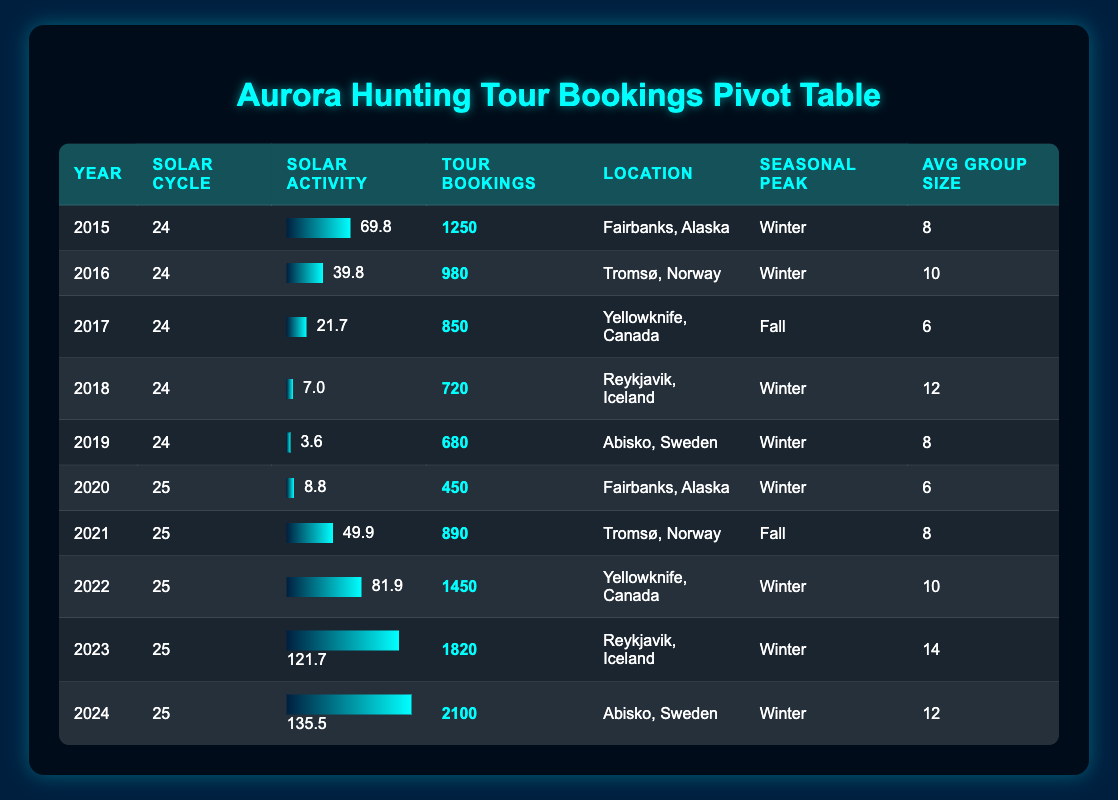What was the year with the highest solar activity index? Looking through the table, the highest solar activity index of 135.5 occurs in the year 2024.
Answer: 2024 Which location had the lowest number of tour bookings? The table shows that the lowest number of tour bookings is 450, which occurred in Fairbanks, Alaska in 2020.
Answer: Fairbanks, Alaska What is the average number of tour bookings for the years 2015 to 2023? Adding all tour bookings from 2015 to 2023 gives (1250 + 980 + 850 + 720 + 680 + 450 + 890 + 1450 + 1820) = 8150. There are 9 data points, so the average is 8150/9 = approximately 905.56.
Answer: 905.56 Did the number of tour bookings in 2023 exceed those in 2022? Comparing the tour bookings, 2023 has 1820 bookings while 2022 has 1450 bookings, which confirms that 1820 is greater than 1450.
Answer: Yes How much did the tour bookings increase from 2020 to 2024? The bookings for 2020 were 450, and for 2024, they are 2100. The increase is calculated as 2100 - 450 = 1650.
Answer: 1650 What percentage of the average group size increased from 2015 (8) to 2023 (14)? The average group size in 2015 was 8 and in 2023 was 14. The increase is 14 - 8 = 6. The percentage increase is (6/8) * 100 = 75%.
Answer: 75% Which solar cycle had more tour bookings on average, Solar Cycle 24 or 25? Solar Cycle 24 has bookings of (1250 + 980 + 850 + 720 + 680) = 3480 for 5 years, averaging 3480/5 = 696. Solar Cycle 25 has bookings of (450 + 890 + 1450 + 1820 + 2100) = 6710 for 5 years, averaging 6710/5 = 1342. Therefore, 1342 > 696.
Answer: Solar Cycle 25 Was there a year when the Solar Activity Index was below 10? Looking through the table, the lowest Solar Activity Index is 3.6 in 2019. Thus, there was indeed a year below 10.
Answer: Yes How many locations had tour bookings greater than 1000 in 2022? In the table for 2022, the location Yellowknife, Canada had 1450 bookings, and Reykjavik, Iceland in 2023 had 1820 bookings, but only 2022 is in question. Thus, one location, Yellowknife, Canada, had bookings over 1000.
Answer: 1 